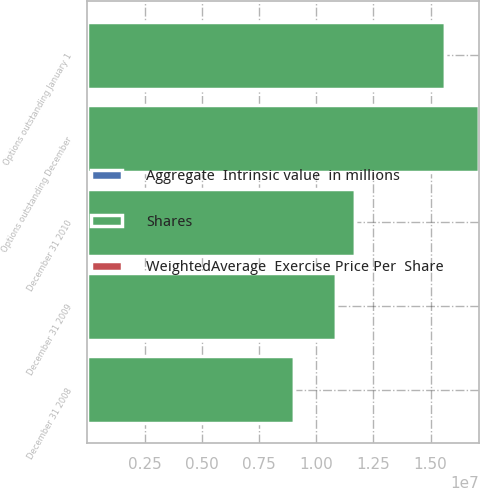Convert chart to OTSL. <chart><loc_0><loc_0><loc_500><loc_500><stacked_bar_chart><ecel><fcel>Options outstanding January 1<fcel>Options outstanding December<fcel>December 31 2008<fcel>December 31 2009<fcel>December 31 2010<nl><fcel>Shares<fcel>1.56235e+07<fcel>1.71158e+07<fcel>9.01168e+06<fcel>1.08693e+07<fcel>1.17129e+07<nl><fcel>WeightedAverage  Exercise Price Per  Share<fcel>29.39<fcel>28.32<fcel>26<fcel>28.36<fcel>29.74<nl><fcel>Aggregate  Intrinsic value  in millions<fcel>133.7<fcel>18<fcel>7.6<fcel>0<fcel>5.8<nl></chart> 